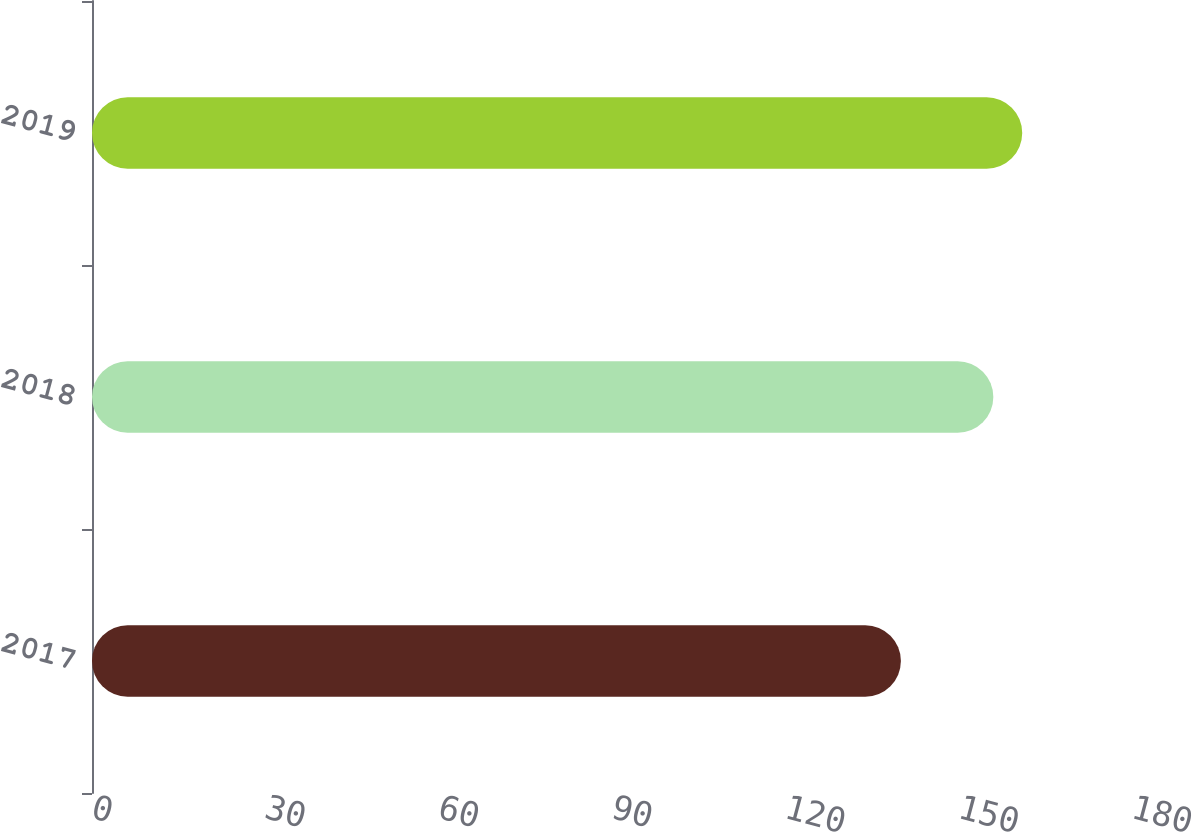Convert chart to OTSL. <chart><loc_0><loc_0><loc_500><loc_500><bar_chart><fcel>2017<fcel>2018<fcel>2019<nl><fcel>140<fcel>156<fcel>161<nl></chart> 